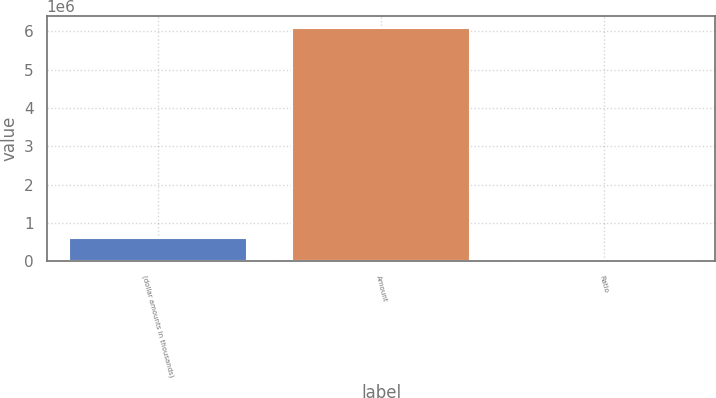Convert chart. <chart><loc_0><loc_0><loc_500><loc_500><bar_chart><fcel>(dollar amounts in thousands)<fcel>Amount<fcel>Ratio<nl><fcel>609974<fcel>6.09963e+06<fcel>12.28<nl></chart> 